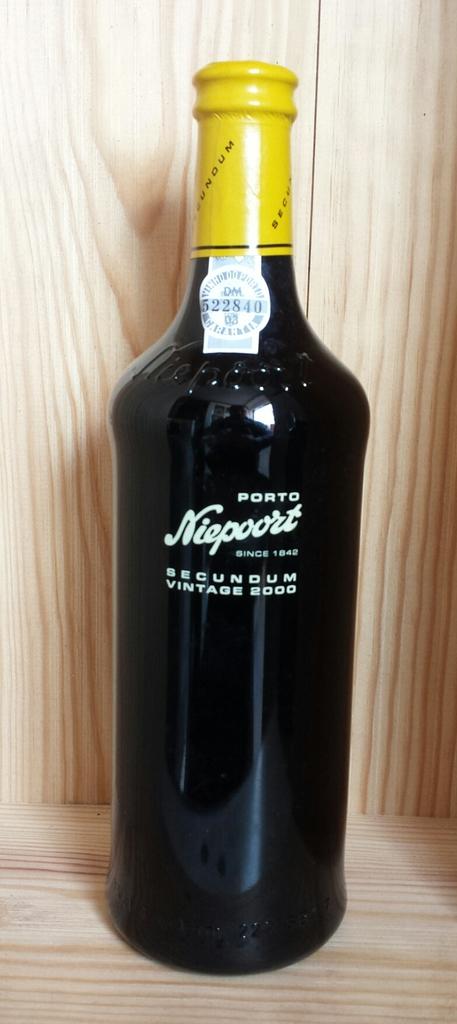What does the year say?
Make the answer very short. 1842. What is the name on the bottle?
Provide a succinct answer. Niepoort. 